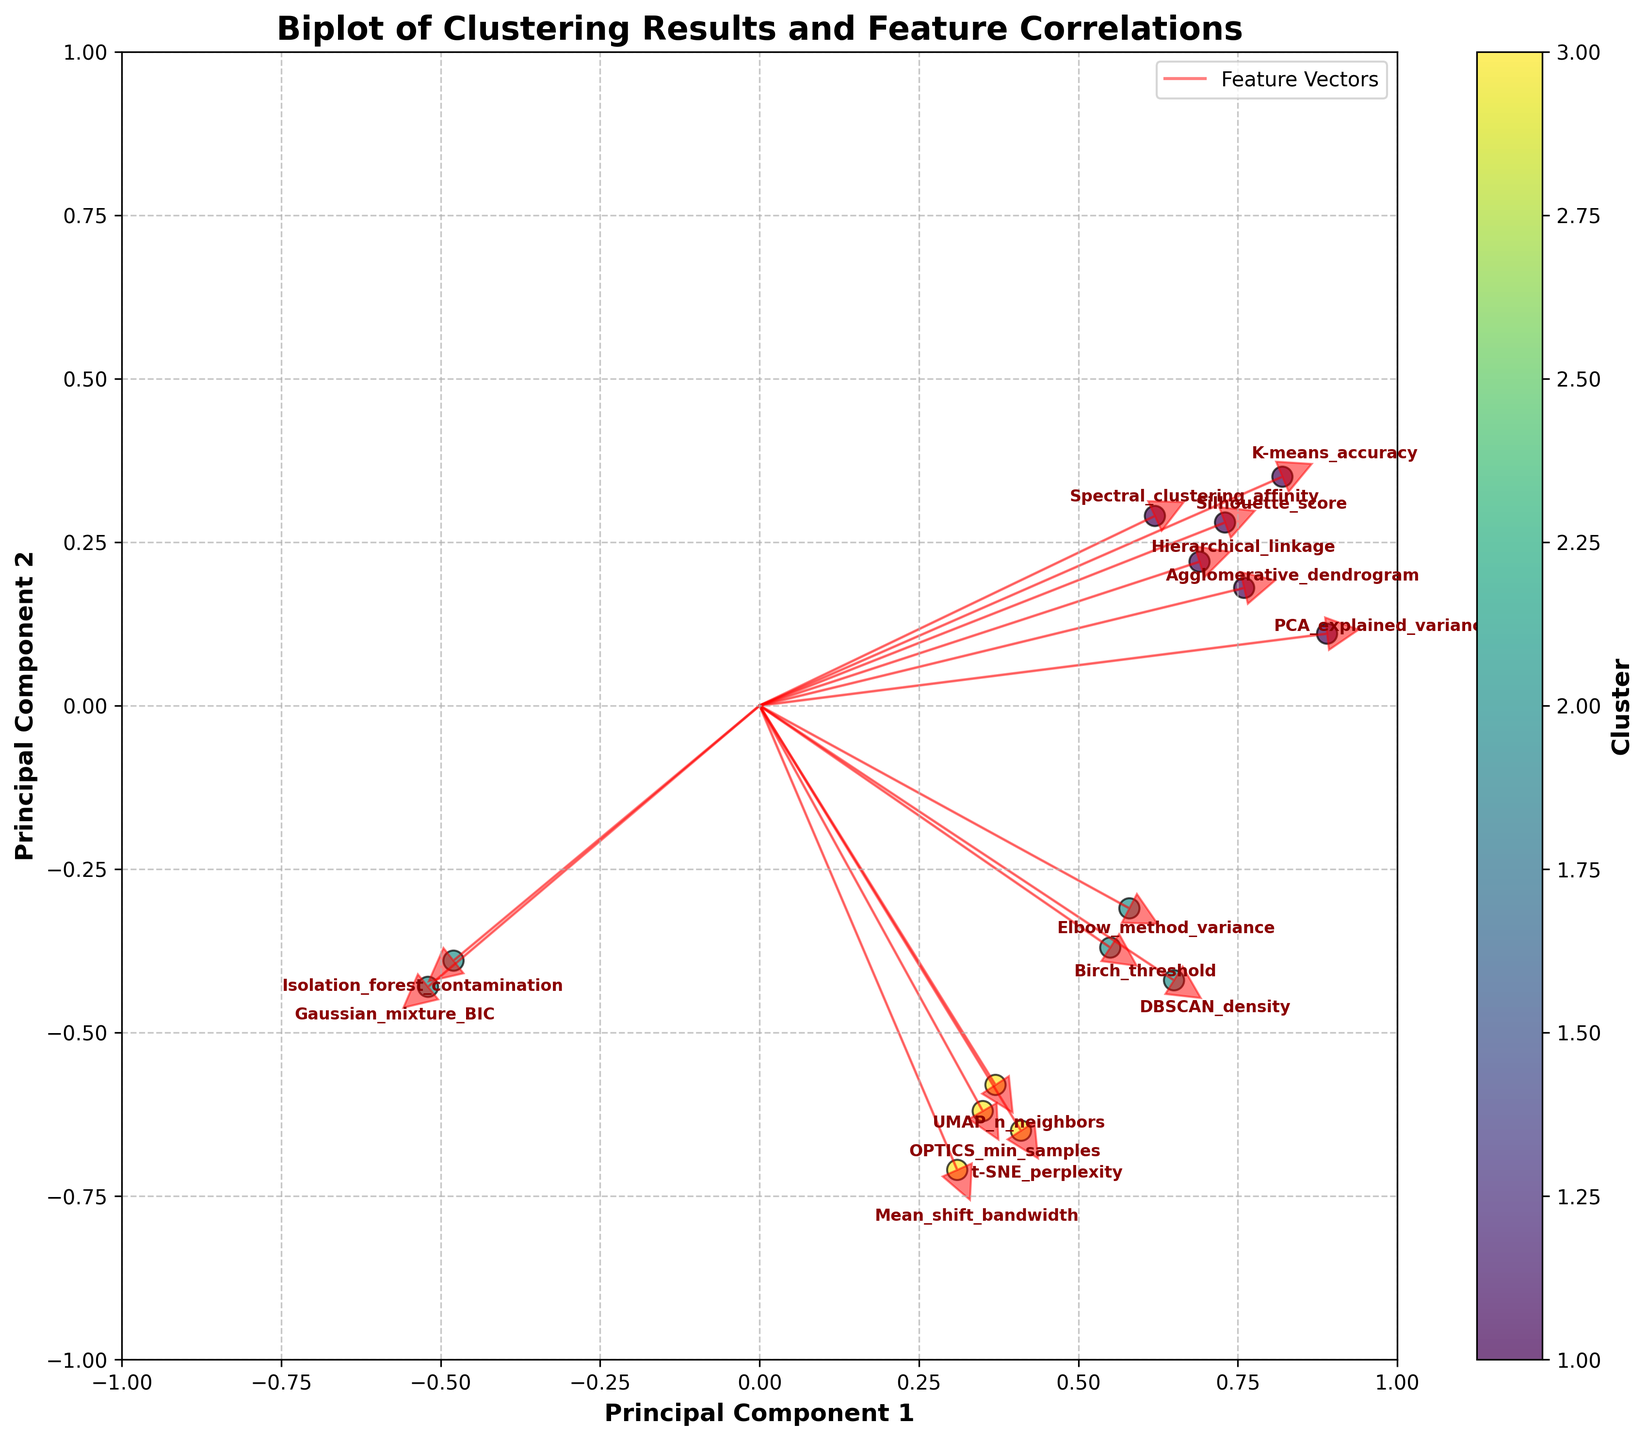What is the title of the figure? The title of the figure is displayed prominently at the top and it reads "Biplot of Clustering Results and Feature Correlations".
Answer: Biplot of Clustering Results and Feature Correlations How many clusters are displayed in the scatter plot? The color of the data points indicates different clusters. By looking at the color bar, we see three distinct clusters labelled 1, 2, and 3.
Answer: 3 Which feature vector has the largest positive value along the PC1 axis? By examining the horizontal positions of the feature vectors, "PCA_explained_variance" has the largest positive PC1 value since it is located furthest to the right.
Answer: PCA_explained_variance How many features have negative values along the PC1 axis? By identifying the features on the left side of the origin (0 on the PC1 axis), we see that "Gaussian_mixture_BIC" and "Isolation_forest_contamination" have negative PC1 values. So, there are two such features.
Answer: 2 Which cluster shows the least variation on the PC1 and PC2 axes? By observing the spread of the clusters on the plot, cluster 3 (features like "Mean_shift_bandwidth", "OPTICS_min_samples", etc.) appears to be the most concentrated compared to clusters 1 and 2.
Answer: Cluster 3 Which feature with Cluster 2 lies furthest in the negative direction on the PC2 axis? By looking at the vertical positioning of features in Cluster 2, "Mean_shift_bandwidth" is located furthest downwards on the PC2 axis.
Answer: Mean_shift_bandwidth Are there any clusters composed exclusively of features that have negative values on the PC2 axis? Cluster 3 contains features "t-SNE_perplexity," "UMAP_n_neighbors," "Mean_shift_bandwidth," and "OPTICS_min_samples," all of which are negative on PC2.
Answer: Yes Which vector represents "Silhouette_score," and what quadrant is it located in? The "Silhouette_score" vector has coordinates (0.73, 0.28), placing it in the first quadrant (both PC1 and PC2 are positive).
Answer: First quadrant Compare the vectors of "K-means_accuracy" and "Hierarchical_linkage." Which has a higher value on the PC2 axis? By examining their positions, "K-means_accuracy" (0.35 on PC2) is higher than "Hierarchical_linkage" (0.22 on PC2).
Answer: K-means_accuracy Identify the feature with the smallest PC1 value. By finding the feature located furthest to the left, "Gaussian_mixture_BIC" has the smallest PC1 value at -0.52.
Answer: Gaussian_mixture_BIC 